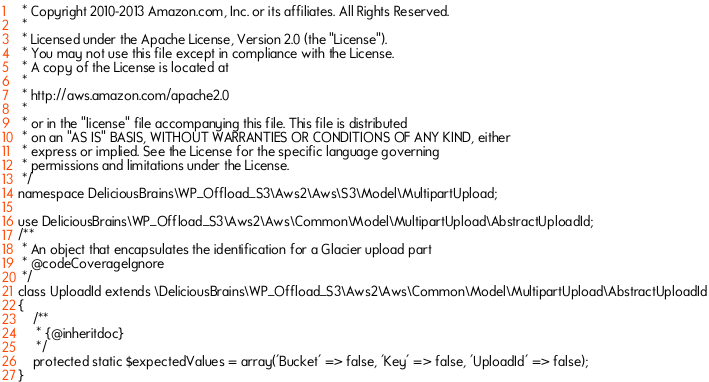Convert code to text. <code><loc_0><loc_0><loc_500><loc_500><_PHP_> * Copyright 2010-2013 Amazon.com, Inc. or its affiliates. All Rights Reserved.
 *
 * Licensed under the Apache License, Version 2.0 (the "License").
 * You may not use this file except in compliance with the License.
 * A copy of the License is located at
 *
 * http://aws.amazon.com/apache2.0
 *
 * or in the "license" file accompanying this file. This file is distributed
 * on an "AS IS" BASIS, WITHOUT WARRANTIES OR CONDITIONS OF ANY KIND, either
 * express or implied. See the License for the specific language governing
 * permissions and limitations under the License.
 */
namespace DeliciousBrains\WP_Offload_S3\Aws2\Aws\S3\Model\MultipartUpload;

use DeliciousBrains\WP_Offload_S3\Aws2\Aws\Common\Model\MultipartUpload\AbstractUploadId;
/**
 * An object that encapsulates the identification for a Glacier upload part
 * @codeCoverageIgnore
 */
class UploadId extends \DeliciousBrains\WP_Offload_S3\Aws2\Aws\Common\Model\MultipartUpload\AbstractUploadId
{
    /**
     * {@inheritdoc}
     */
    protected static $expectedValues = array('Bucket' => false, 'Key' => false, 'UploadId' => false);
}
</code> 